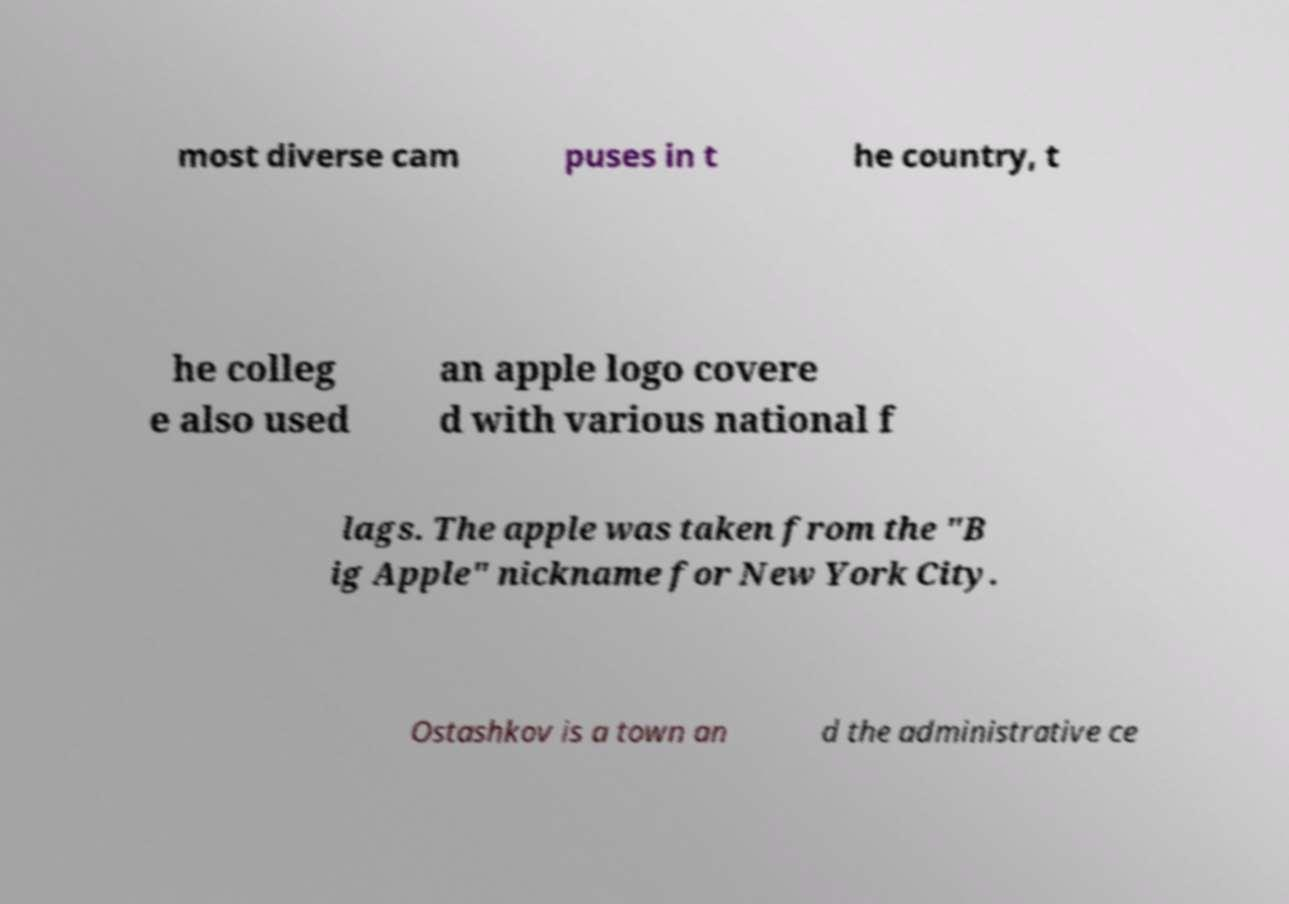Please read and relay the text visible in this image. What does it say? most diverse cam puses in t he country, t he colleg e also used an apple logo covere d with various national f lags. The apple was taken from the "B ig Apple" nickname for New York City. Ostashkov is a town an d the administrative ce 